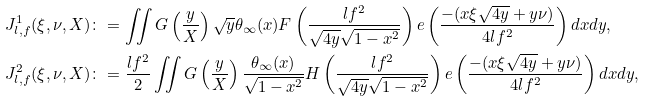<formula> <loc_0><loc_0><loc_500><loc_500>J ^ { 1 } _ { l , f } ( \xi , \nu , X ) & \colon = \iint G \left ( \frac { y } { X } \right ) \sqrt { y } \theta _ { \infty } ( x ) F \left ( \frac { l f ^ { 2 } } { \sqrt { 4 y } \sqrt { 1 - x ^ { 2 } } } \right ) e \left ( \frac { - ( x \xi \sqrt { 4 y } + y \nu ) } { 4 l f ^ { 2 } } \right ) d x d y , \\ J ^ { 2 } _ { l , f } ( \xi , \nu , X ) & \colon = \frac { l f ^ { 2 } } { 2 } \iint G \left ( \frac { y } { X } \right ) \frac { \theta _ { \infty } ( x ) } { \sqrt { 1 - x ^ { 2 } } } H \left ( \frac { l f ^ { 2 } } { \sqrt { 4 y } \sqrt { 1 - x ^ { 2 } } } \right ) e \left ( \frac { - ( x \xi \sqrt { 4 y } + y \nu ) } { 4 l f ^ { 2 } } \right ) d x d y ,</formula> 